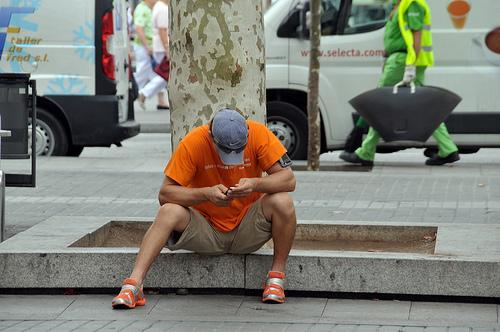What device is the one most probably attached to the man's arm?

Choices:
A) game
B) music player
C) phone
D) hard drive music player 